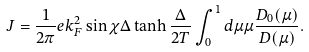Convert formula to latex. <formula><loc_0><loc_0><loc_500><loc_500>J = \frac { 1 } { 2 \pi } e k _ { F } ^ { 2 } \sin \chi \Delta \tanh \frac { \Delta } { 2 T } \int _ { 0 } ^ { 1 } d \mu \mu \frac { D _ { 0 } ( \mu ) } { D ( \mu ) } .</formula> 